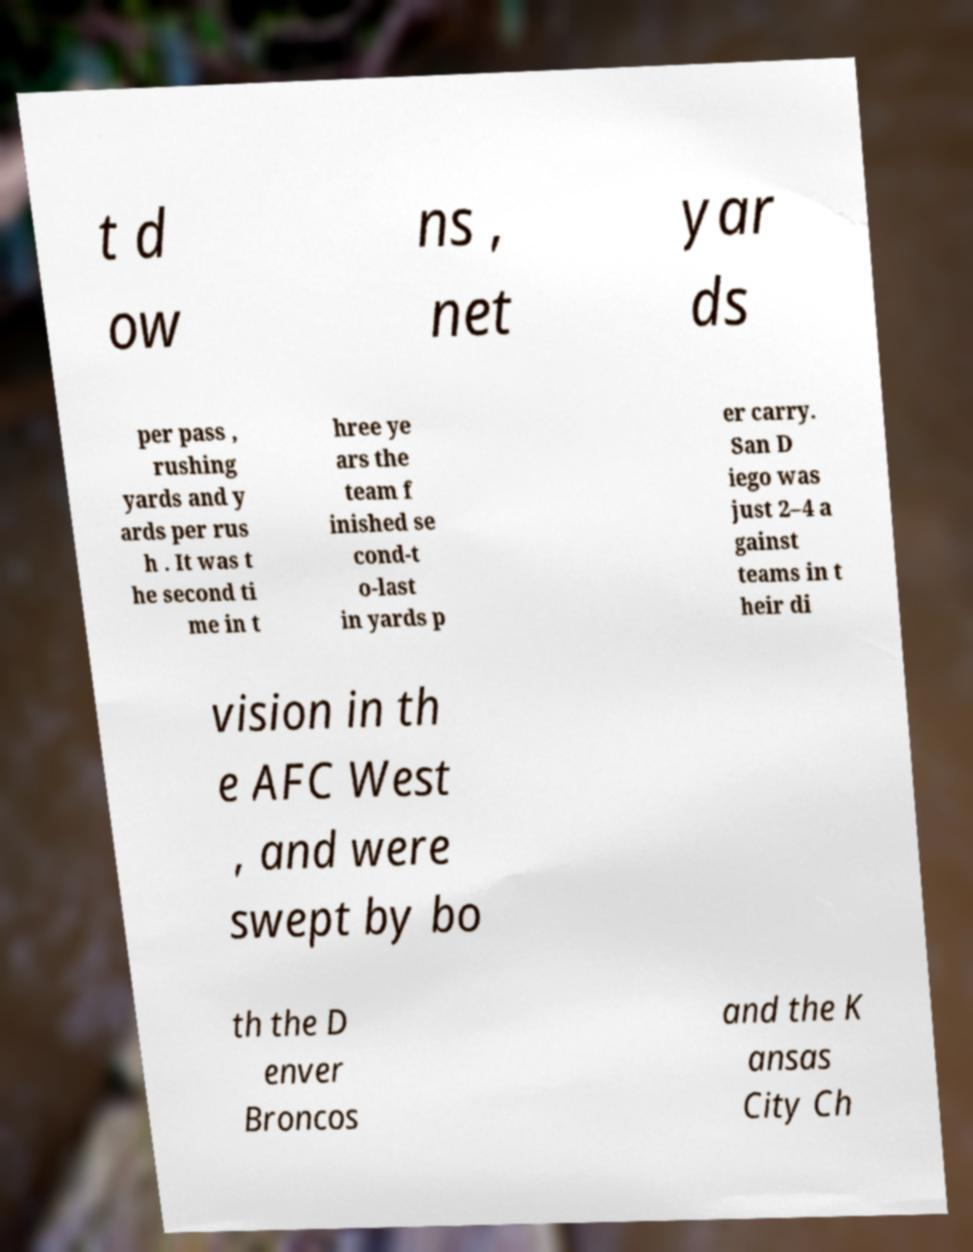Can you accurately transcribe the text from the provided image for me? t d ow ns , net yar ds per pass , rushing yards and y ards per rus h . It was t he second ti me in t hree ye ars the team f inished se cond-t o-last in yards p er carry. San D iego was just 2–4 a gainst teams in t heir di vision in th e AFC West , and were swept by bo th the D enver Broncos and the K ansas City Ch 